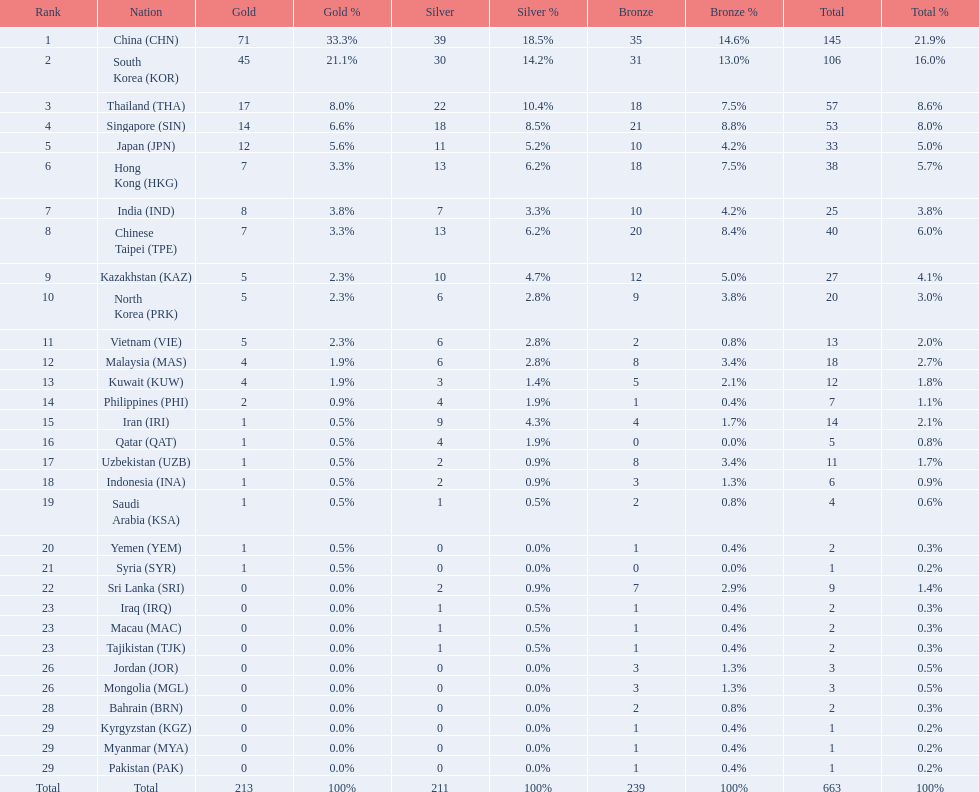Which countries have the same number of silver medals in the asian youth games as north korea? Vietnam (VIE), Malaysia (MAS). 